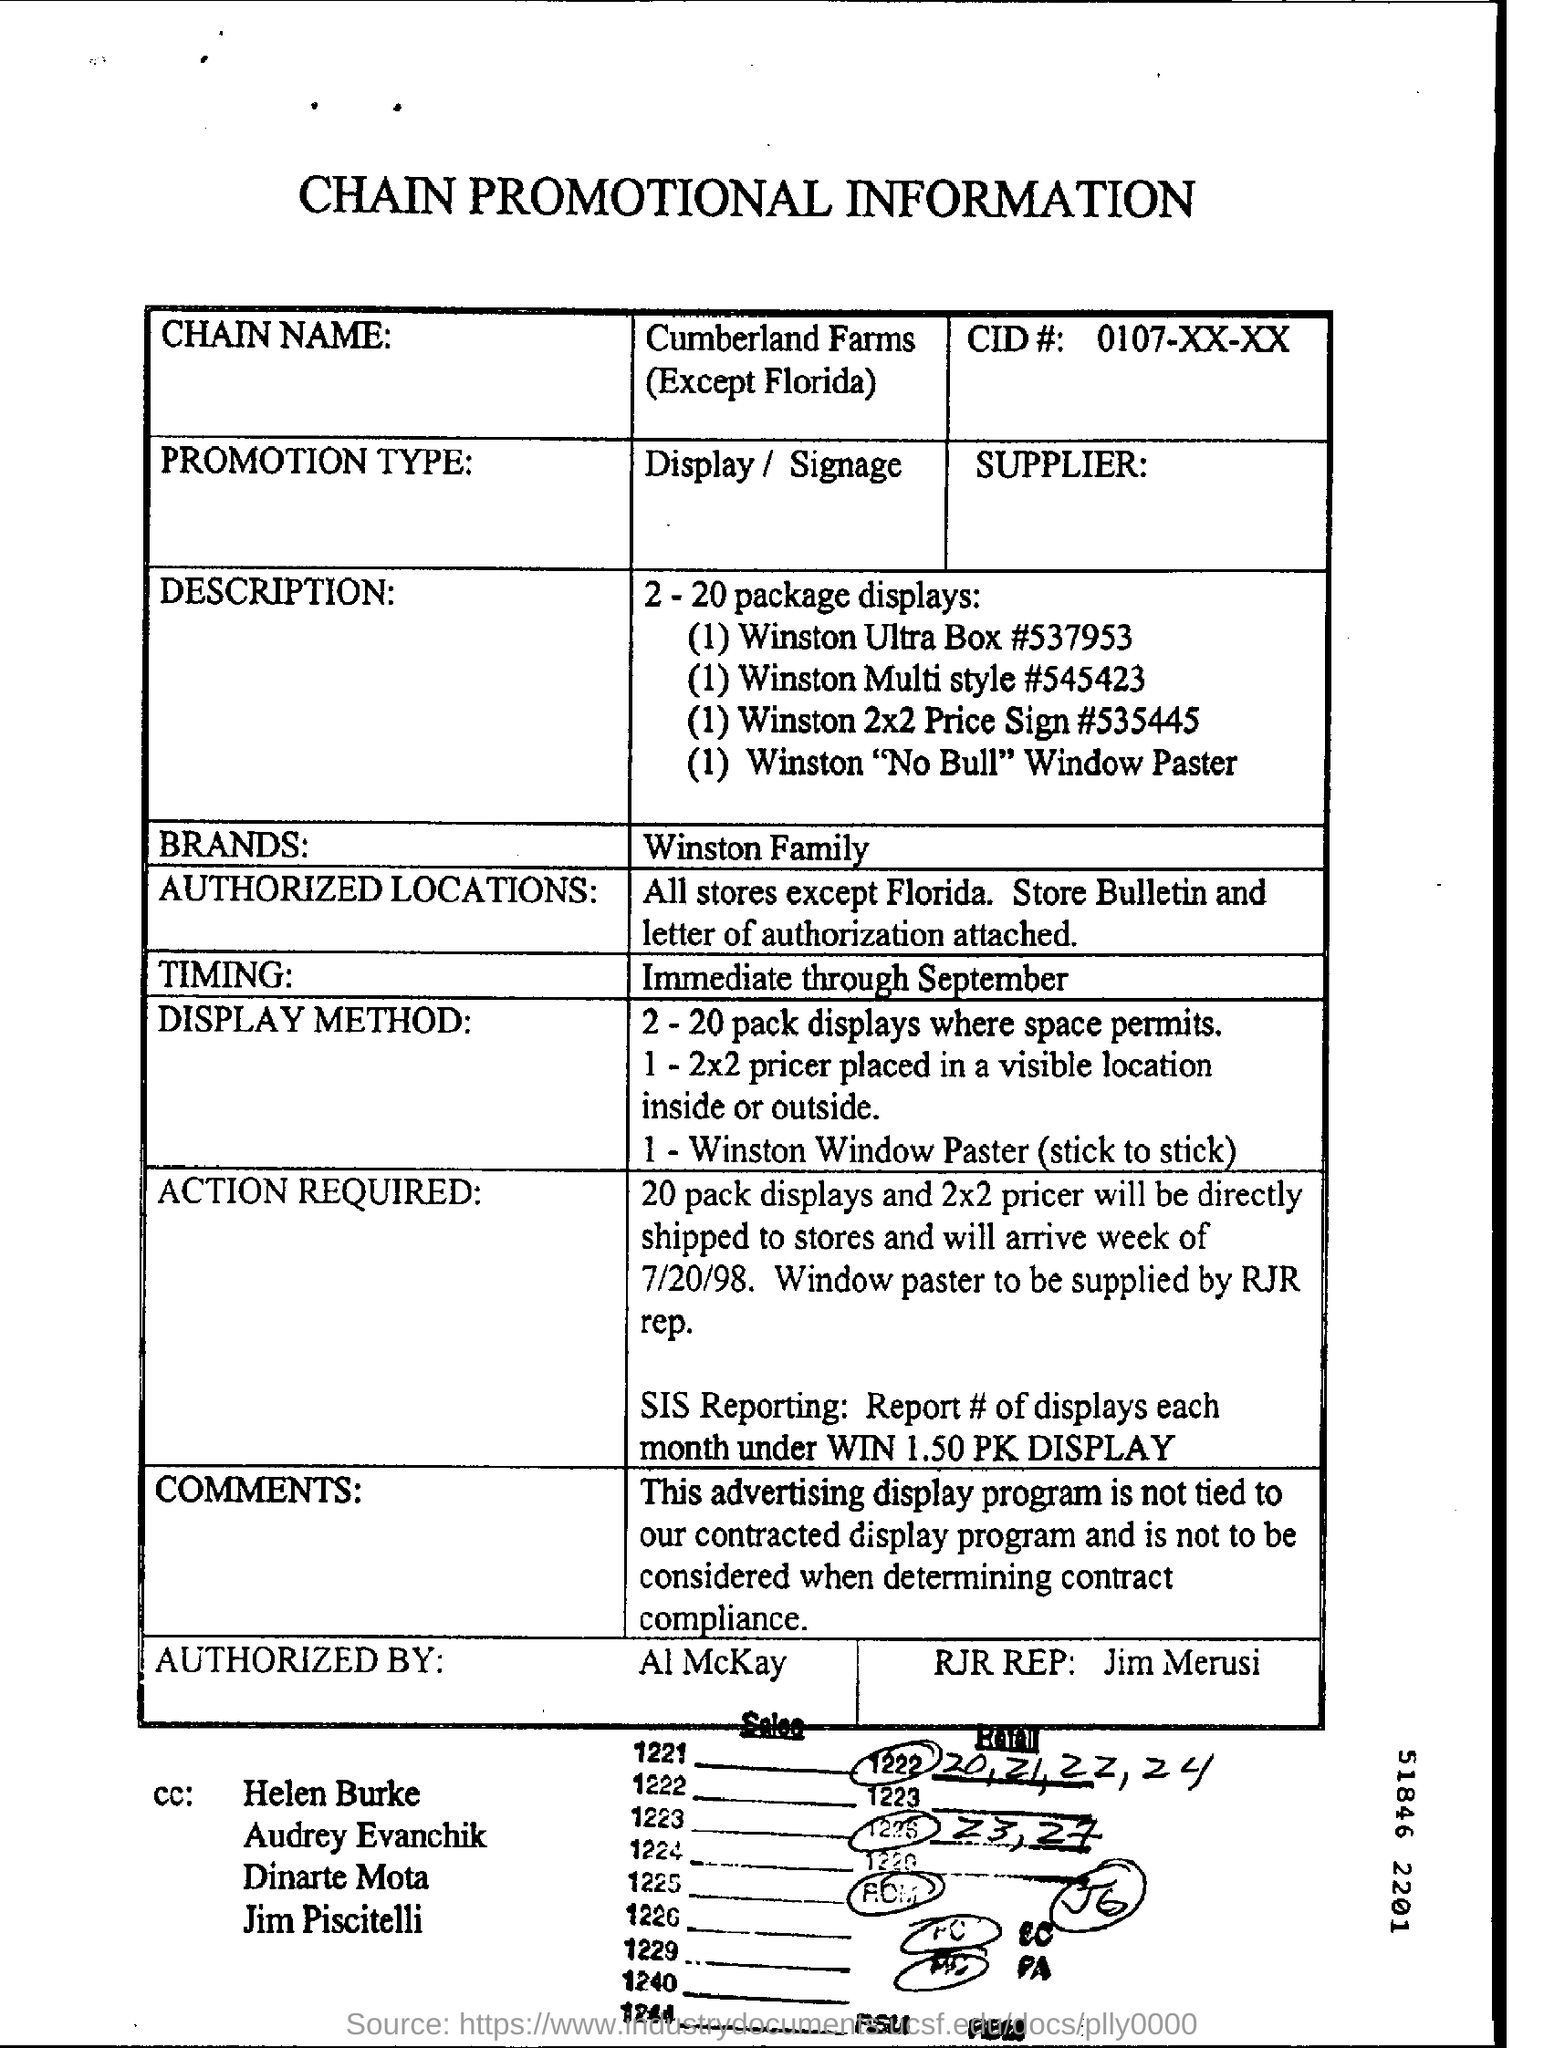What is the type of promotion?
Give a very brief answer. Display / signage. What is the chain name?
Ensure brevity in your answer.  Cumberland Farms (Except Florida). What is the CID#?
Give a very brief answer. 0107-XX-XX. What is the brand mentioned?
Offer a very short reply. Winston Family. 